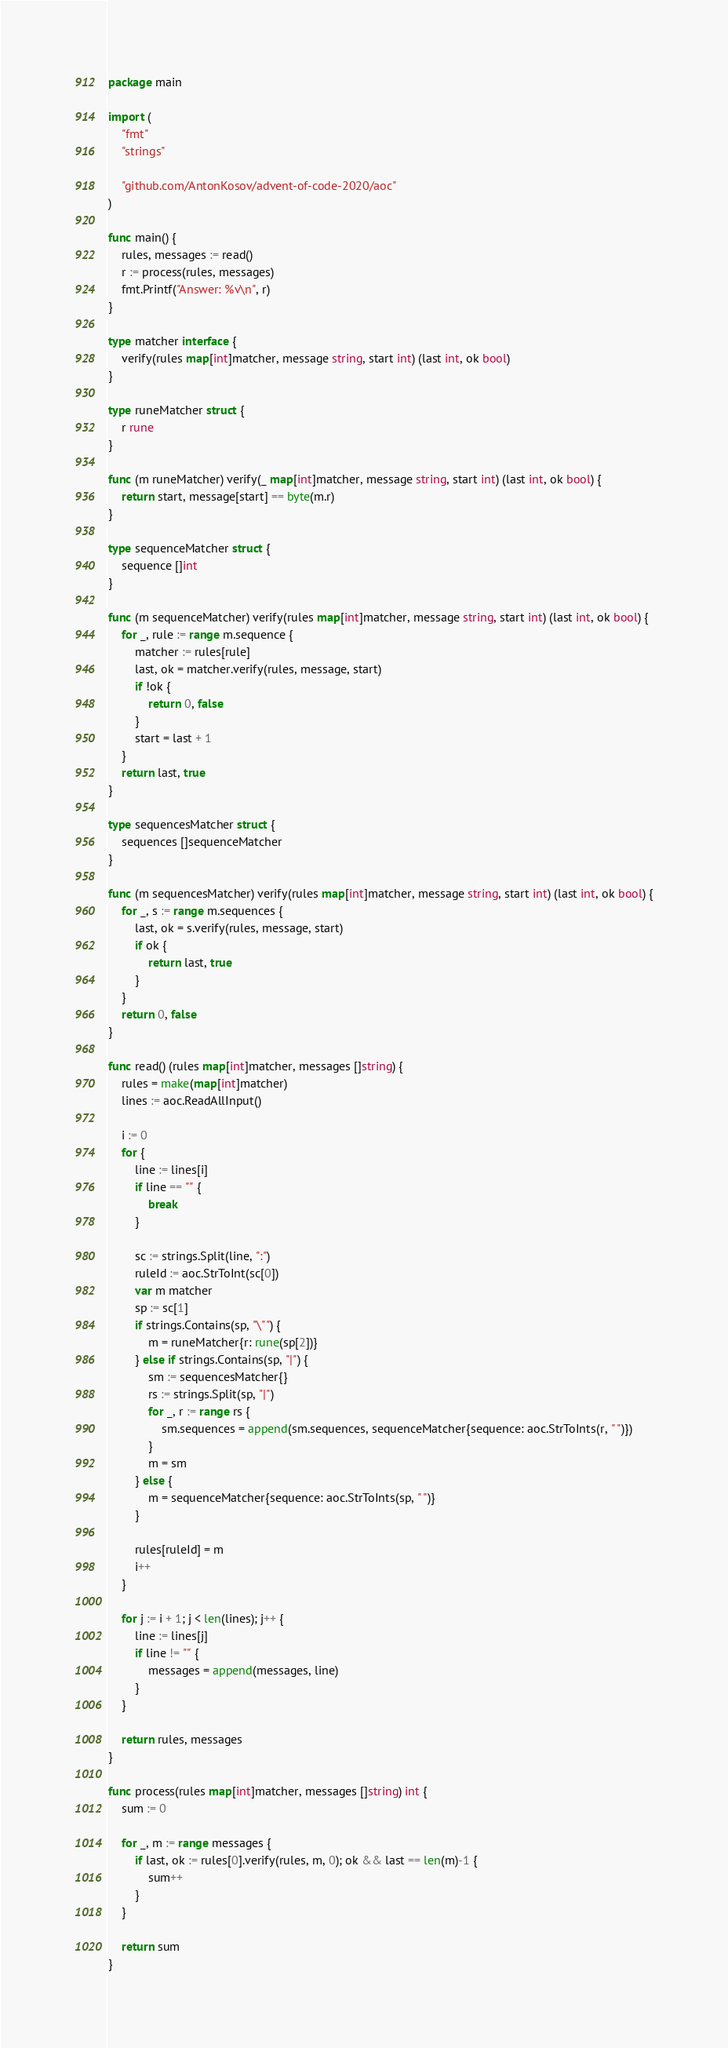Convert code to text. <code><loc_0><loc_0><loc_500><loc_500><_Go_>package main

import (
	"fmt"
	"strings"

	"github.com/AntonKosov/advent-of-code-2020/aoc"
)

func main() {
	rules, messages := read()
	r := process(rules, messages)
	fmt.Printf("Answer: %v\n", r)
}

type matcher interface {
	verify(rules map[int]matcher, message string, start int) (last int, ok bool)
}

type runeMatcher struct {
	r rune
}

func (m runeMatcher) verify(_ map[int]matcher, message string, start int) (last int, ok bool) {
	return start, message[start] == byte(m.r)
}

type sequenceMatcher struct {
	sequence []int
}

func (m sequenceMatcher) verify(rules map[int]matcher, message string, start int) (last int, ok bool) {
	for _, rule := range m.sequence {
		matcher := rules[rule]
		last, ok = matcher.verify(rules, message, start)
		if !ok {
			return 0, false
		}
		start = last + 1
	}
	return last, true
}

type sequencesMatcher struct {
	sequences []sequenceMatcher
}

func (m sequencesMatcher) verify(rules map[int]matcher, message string, start int) (last int, ok bool) {
	for _, s := range m.sequences {
		last, ok = s.verify(rules, message, start)
		if ok {
			return last, true
		}
	}
	return 0, false
}

func read() (rules map[int]matcher, messages []string) {
	rules = make(map[int]matcher)
	lines := aoc.ReadAllInput()

	i := 0
	for {
		line := lines[i]
		if line == "" {
			break
		}

		sc := strings.Split(line, ":")
		ruleId := aoc.StrToInt(sc[0])
		var m matcher
		sp := sc[1]
		if strings.Contains(sp, "\"") {
			m = runeMatcher{r: rune(sp[2])}
		} else if strings.Contains(sp, "|") {
			sm := sequencesMatcher{}
			rs := strings.Split(sp, "|")
			for _, r := range rs {
				sm.sequences = append(sm.sequences, sequenceMatcher{sequence: aoc.StrToInts(r, " ")})
			}
			m = sm
		} else {
			m = sequenceMatcher{sequence: aoc.StrToInts(sp, " ")}
		}

		rules[ruleId] = m
		i++
	}

	for j := i + 1; j < len(lines); j++ {
		line := lines[j]
		if line != "" {
			messages = append(messages, line)
		}
	}

	return rules, messages
}

func process(rules map[int]matcher, messages []string) int {
	sum := 0

	for _, m := range messages {
		if last, ok := rules[0].verify(rules, m, 0); ok && last == len(m)-1 {
			sum++
		}
	}

	return sum
}
</code> 